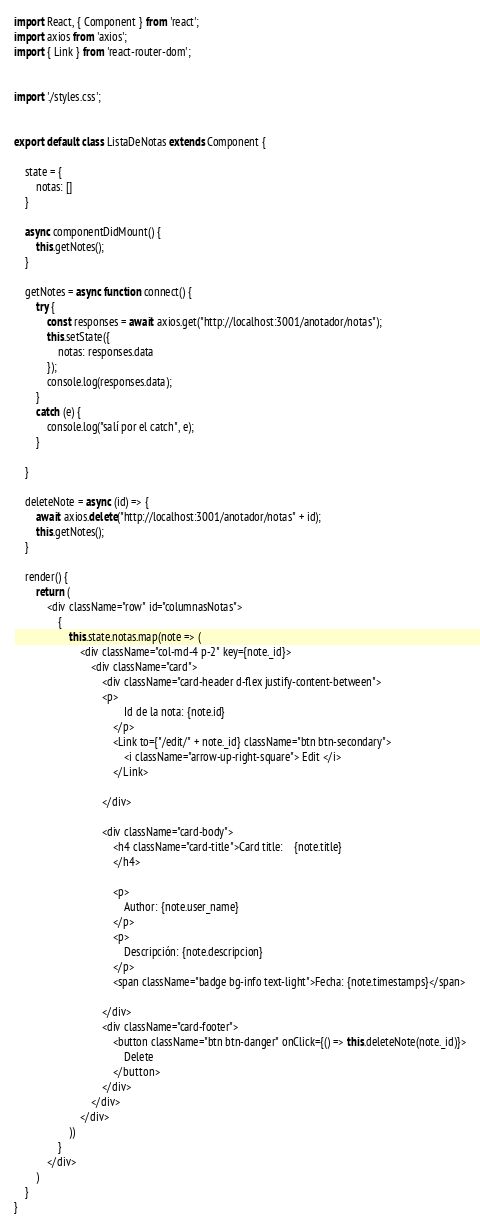<code> <loc_0><loc_0><loc_500><loc_500><_JavaScript_>import React, { Component } from 'react';
import axios from 'axios';
import { Link } from 'react-router-dom';


import './styles.css';


export default class ListaDeNotas extends Component {

    state = {
        notas: []
    }

    async componentDidMount() {
        this.getNotes();
    }

    getNotes = async function connect() {
        try {
            const responses = await axios.get("http://localhost:3001/anotador/notas");
            this.setState({
                notas: responses.data
            });
            console.log(responses.data);
        }
        catch (e) {
            console.log("salí por el catch", e);
        }

    }

    deleteNote = async (id) => {
        await axios.delete("http://localhost:3001/anotador/notas" + id);
        this.getNotes();
    }

    render() {
        return (
            <div className="row" id="columnasNotas">
                {
                    this.state.notas.map(note => (
                        <div className="col-md-4 p-2" key={note._id}>
                            <div className="card">
                                <div className="card-header d-flex justify-content-between">
                                <p>
                                        Id de la nota: {note.id}
                                    </p>
                                    <Link to={"/edit/" + note._id} className="btn btn-secondary">
                                        <i className="arrow-up-right-square"> Edit </i>
                                    </Link>

                                </div>

                                <div className="card-body">
                                    <h4 className="card-title">Card title:    {note.title}
                                    </h4>

                                    <p>
                                        Author: {note.user_name}
                                    </p>
                                    <p>
                                        Descripción: {note.descripcion}
                                    </p>
                                    <span className="badge bg-info text-light">Fecha: {note.timestamps}</span>

                                </div>
                                <div className="card-footer">
                                    <button className="btn btn-danger" onClick={() => this.deleteNote(note._id)}>
                                        Delete
                                    </button>
                                </div>
                            </div>
                        </div>
                    ))
                }
            </div>
        )
    }
}
</code> 